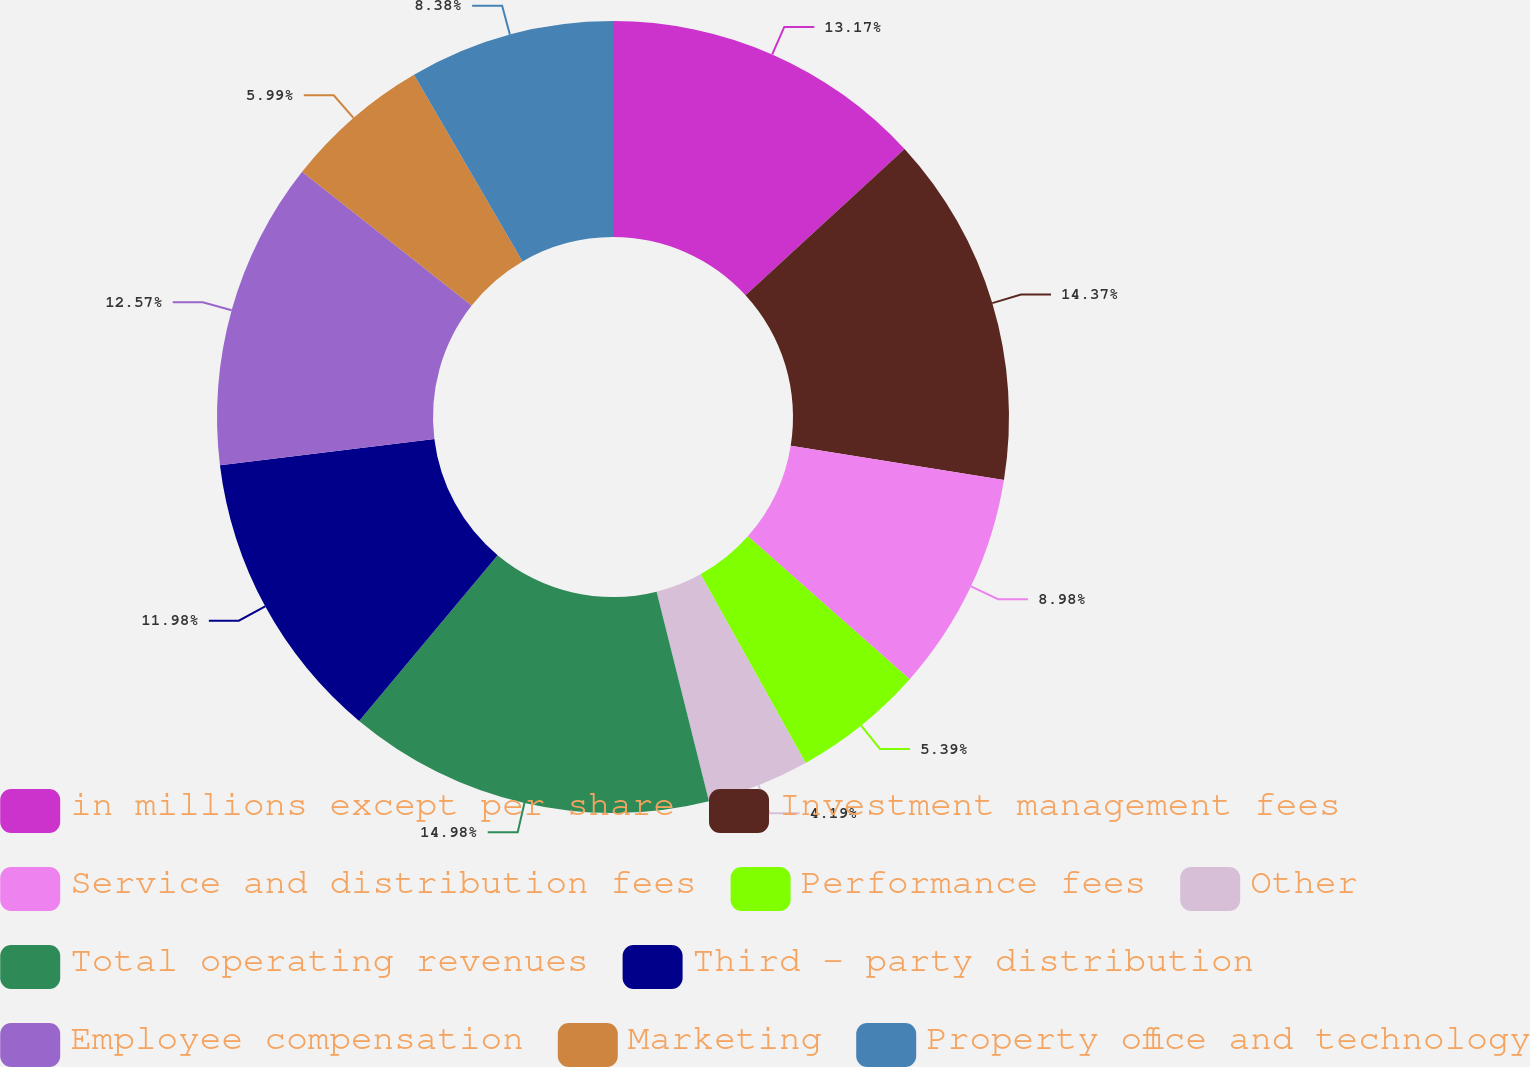Convert chart. <chart><loc_0><loc_0><loc_500><loc_500><pie_chart><fcel>in millions except per share<fcel>Investment management fees<fcel>Service and distribution fees<fcel>Performance fees<fcel>Other<fcel>Total operating revenues<fcel>Third - party distribution<fcel>Employee compensation<fcel>Marketing<fcel>Property office and technology<nl><fcel>13.17%<fcel>14.37%<fcel>8.98%<fcel>5.39%<fcel>4.19%<fcel>14.97%<fcel>11.98%<fcel>12.57%<fcel>5.99%<fcel>8.38%<nl></chart> 